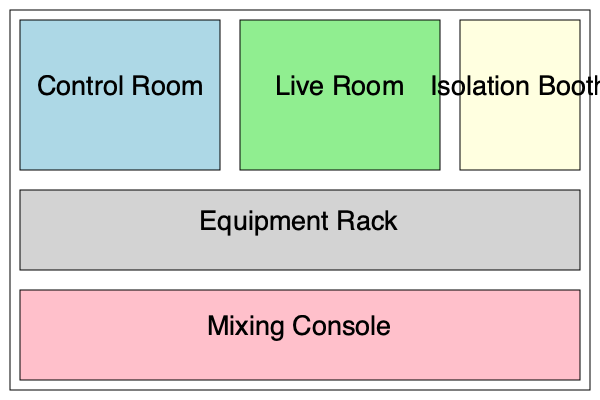In a typical recording studio setup, which room is specifically designed for housing the main recording equipment and where the sound engineer primarily works? To answer this question, let's break down the components of a typical recording studio setup:

1. Control Room: This is the primary workspace for the sound engineer. It houses the main recording equipment, including the mixing console, monitors, and computer workstations. The control room is where the engineer manages the recording process, adjusts levels, and performs mixing and editing tasks.

2. Live Room: This is the main recording space where musicians perform. It's typically larger than the control room and is acoustically treated to achieve the desired sound quality.

3. Isolation Booth: This is a smaller, soundproofed room used for recording individual instruments or vocals that need to be isolated from other sounds.

4. Equipment Rack: This area houses various outboard gear, such as preamps, compressors, and effects processors.

5. Mixing Console: This is the central hub for managing audio signals, typically located in the control room.

Given that the question asks about the room designed for housing the main recording equipment and where the sound engineer primarily works, the correct answer is the Control Room. This is where the majority of the technical work happens, including operating the mixing console, monitoring the recordings, and making adjustments to the sound.
Answer: Control Room 